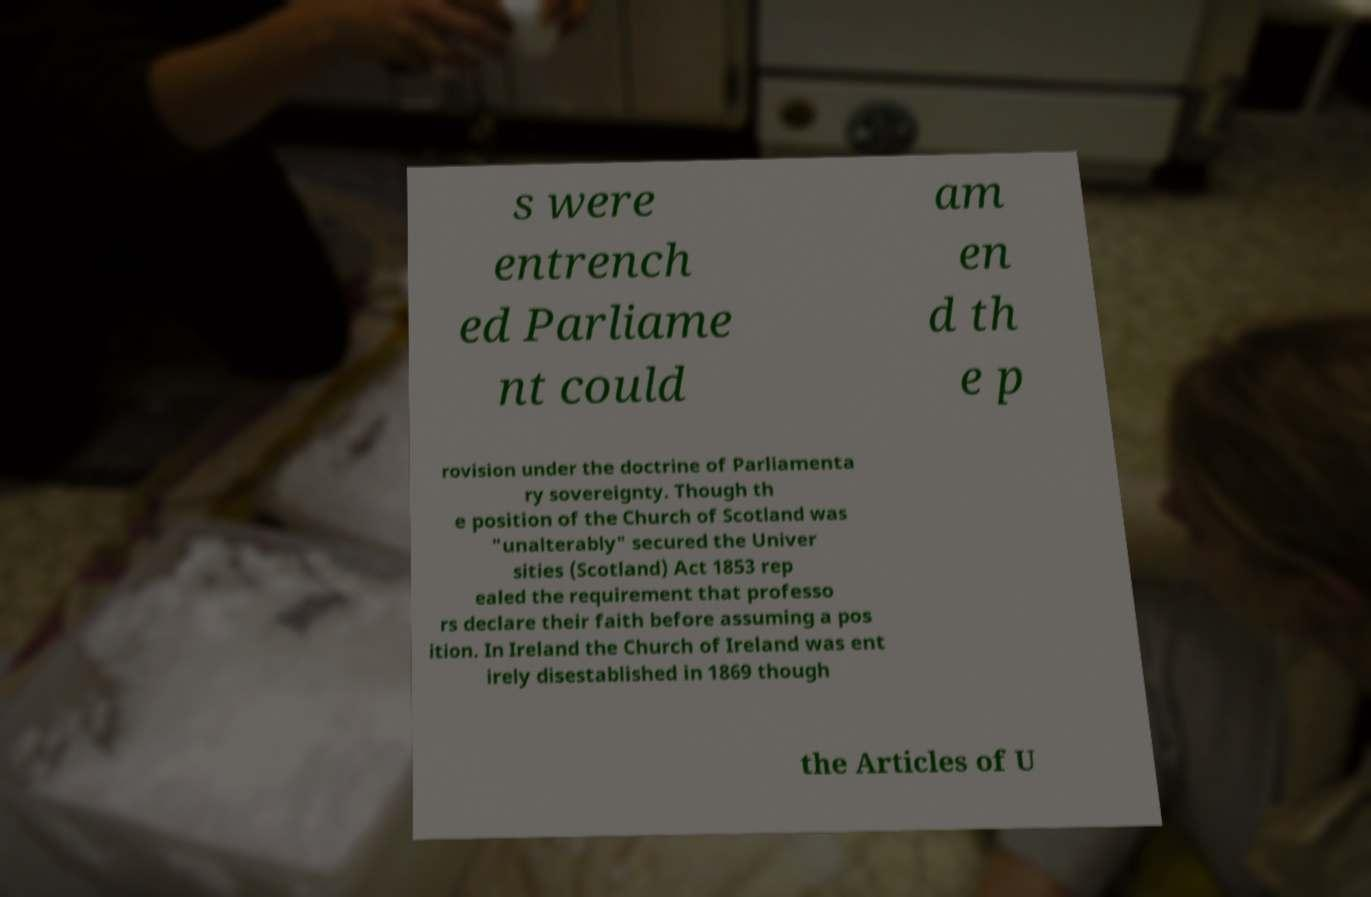Can you read and provide the text displayed in the image?This photo seems to have some interesting text. Can you extract and type it out for me? s were entrench ed Parliame nt could am en d th e p rovision under the doctrine of Parliamenta ry sovereignty. Though th e position of the Church of Scotland was "unalterably" secured the Univer sities (Scotland) Act 1853 rep ealed the requirement that professo rs declare their faith before assuming a pos ition. In Ireland the Church of Ireland was ent irely disestablished in 1869 though the Articles of U 